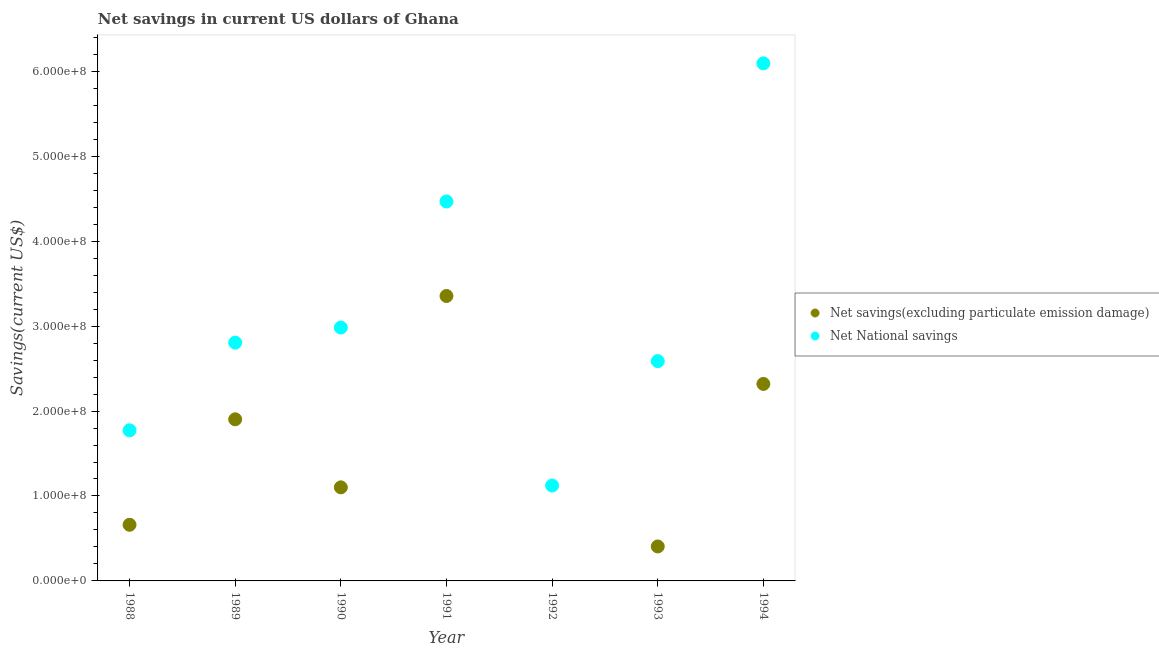How many different coloured dotlines are there?
Make the answer very short. 2. Is the number of dotlines equal to the number of legend labels?
Give a very brief answer. No. What is the net savings(excluding particulate emission damage) in 1991?
Provide a short and direct response. 3.35e+08. Across all years, what is the maximum net savings(excluding particulate emission damage)?
Ensure brevity in your answer.  3.35e+08. Across all years, what is the minimum net national savings?
Your answer should be very brief. 1.12e+08. What is the total net savings(excluding particulate emission damage) in the graph?
Keep it short and to the point. 9.75e+08. What is the difference between the net national savings in 1990 and that in 1991?
Provide a short and direct response. -1.48e+08. What is the difference between the net savings(excluding particulate emission damage) in 1989 and the net national savings in 1988?
Your response must be concise. 1.30e+07. What is the average net national savings per year?
Ensure brevity in your answer.  3.12e+08. In the year 1994, what is the difference between the net national savings and net savings(excluding particulate emission damage)?
Provide a succinct answer. 3.77e+08. What is the ratio of the net national savings in 1990 to that in 1994?
Provide a short and direct response. 0.49. Is the difference between the net savings(excluding particulate emission damage) in 1988 and 1993 greater than the difference between the net national savings in 1988 and 1993?
Ensure brevity in your answer.  Yes. What is the difference between the highest and the second highest net national savings?
Offer a very short reply. 1.63e+08. What is the difference between the highest and the lowest net national savings?
Give a very brief answer. 4.97e+08. In how many years, is the net national savings greater than the average net national savings taken over all years?
Keep it short and to the point. 2. Is the sum of the net national savings in 1990 and 1991 greater than the maximum net savings(excluding particulate emission damage) across all years?
Your answer should be compact. Yes. Is the net national savings strictly greater than the net savings(excluding particulate emission damage) over the years?
Offer a terse response. Yes. Is the net savings(excluding particulate emission damage) strictly less than the net national savings over the years?
Make the answer very short. Yes. How many years are there in the graph?
Make the answer very short. 7. What is the difference between two consecutive major ticks on the Y-axis?
Your answer should be very brief. 1.00e+08. Are the values on the major ticks of Y-axis written in scientific E-notation?
Offer a very short reply. Yes. How many legend labels are there?
Ensure brevity in your answer.  2. What is the title of the graph?
Your answer should be very brief. Net savings in current US dollars of Ghana. Does "Males" appear as one of the legend labels in the graph?
Ensure brevity in your answer.  No. What is the label or title of the Y-axis?
Give a very brief answer. Savings(current US$). What is the Savings(current US$) in Net savings(excluding particulate emission damage) in 1988?
Your response must be concise. 6.61e+07. What is the Savings(current US$) of Net National savings in 1988?
Your answer should be very brief. 1.77e+08. What is the Savings(current US$) in Net savings(excluding particulate emission damage) in 1989?
Your answer should be compact. 1.90e+08. What is the Savings(current US$) of Net National savings in 1989?
Your answer should be very brief. 2.81e+08. What is the Savings(current US$) in Net savings(excluding particulate emission damage) in 1990?
Provide a short and direct response. 1.10e+08. What is the Savings(current US$) of Net National savings in 1990?
Offer a terse response. 2.98e+08. What is the Savings(current US$) of Net savings(excluding particulate emission damage) in 1991?
Your answer should be very brief. 3.35e+08. What is the Savings(current US$) in Net National savings in 1991?
Your answer should be compact. 4.47e+08. What is the Savings(current US$) of Net savings(excluding particulate emission damage) in 1992?
Provide a succinct answer. 0. What is the Savings(current US$) in Net National savings in 1992?
Provide a succinct answer. 1.12e+08. What is the Savings(current US$) in Net savings(excluding particulate emission damage) in 1993?
Offer a very short reply. 4.06e+07. What is the Savings(current US$) of Net National savings in 1993?
Provide a succinct answer. 2.59e+08. What is the Savings(current US$) of Net savings(excluding particulate emission damage) in 1994?
Your response must be concise. 2.32e+08. What is the Savings(current US$) in Net National savings in 1994?
Give a very brief answer. 6.09e+08. Across all years, what is the maximum Savings(current US$) in Net savings(excluding particulate emission damage)?
Your answer should be very brief. 3.35e+08. Across all years, what is the maximum Savings(current US$) of Net National savings?
Provide a short and direct response. 6.09e+08. Across all years, what is the minimum Savings(current US$) of Net National savings?
Provide a short and direct response. 1.12e+08. What is the total Savings(current US$) in Net savings(excluding particulate emission damage) in the graph?
Make the answer very short. 9.75e+08. What is the total Savings(current US$) of Net National savings in the graph?
Your answer should be very brief. 2.18e+09. What is the difference between the Savings(current US$) of Net savings(excluding particulate emission damage) in 1988 and that in 1989?
Your response must be concise. -1.24e+08. What is the difference between the Savings(current US$) of Net National savings in 1988 and that in 1989?
Make the answer very short. -1.03e+08. What is the difference between the Savings(current US$) of Net savings(excluding particulate emission damage) in 1988 and that in 1990?
Provide a short and direct response. -4.41e+07. What is the difference between the Savings(current US$) of Net National savings in 1988 and that in 1990?
Your answer should be very brief. -1.21e+08. What is the difference between the Savings(current US$) of Net savings(excluding particulate emission damage) in 1988 and that in 1991?
Your answer should be compact. -2.69e+08. What is the difference between the Savings(current US$) in Net National savings in 1988 and that in 1991?
Offer a very short reply. -2.69e+08. What is the difference between the Savings(current US$) in Net National savings in 1988 and that in 1992?
Give a very brief answer. 6.51e+07. What is the difference between the Savings(current US$) in Net savings(excluding particulate emission damage) in 1988 and that in 1993?
Offer a terse response. 2.55e+07. What is the difference between the Savings(current US$) of Net National savings in 1988 and that in 1993?
Keep it short and to the point. -8.14e+07. What is the difference between the Savings(current US$) of Net savings(excluding particulate emission damage) in 1988 and that in 1994?
Your response must be concise. -1.66e+08. What is the difference between the Savings(current US$) in Net National savings in 1988 and that in 1994?
Your answer should be very brief. -4.32e+08. What is the difference between the Savings(current US$) of Net savings(excluding particulate emission damage) in 1989 and that in 1990?
Offer a terse response. 8.01e+07. What is the difference between the Savings(current US$) in Net National savings in 1989 and that in 1990?
Give a very brief answer. -1.78e+07. What is the difference between the Savings(current US$) in Net savings(excluding particulate emission damage) in 1989 and that in 1991?
Ensure brevity in your answer.  -1.45e+08. What is the difference between the Savings(current US$) of Net National savings in 1989 and that in 1991?
Your answer should be compact. -1.66e+08. What is the difference between the Savings(current US$) in Net National savings in 1989 and that in 1992?
Ensure brevity in your answer.  1.68e+08. What is the difference between the Savings(current US$) in Net savings(excluding particulate emission damage) in 1989 and that in 1993?
Keep it short and to the point. 1.50e+08. What is the difference between the Savings(current US$) of Net National savings in 1989 and that in 1993?
Your answer should be compact. 2.18e+07. What is the difference between the Savings(current US$) of Net savings(excluding particulate emission damage) in 1989 and that in 1994?
Make the answer very short. -4.17e+07. What is the difference between the Savings(current US$) of Net National savings in 1989 and that in 1994?
Your response must be concise. -3.29e+08. What is the difference between the Savings(current US$) in Net savings(excluding particulate emission damage) in 1990 and that in 1991?
Provide a succinct answer. -2.25e+08. What is the difference between the Savings(current US$) in Net National savings in 1990 and that in 1991?
Provide a succinct answer. -1.48e+08. What is the difference between the Savings(current US$) of Net National savings in 1990 and that in 1992?
Ensure brevity in your answer.  1.86e+08. What is the difference between the Savings(current US$) in Net savings(excluding particulate emission damage) in 1990 and that in 1993?
Your answer should be compact. 6.96e+07. What is the difference between the Savings(current US$) in Net National savings in 1990 and that in 1993?
Your answer should be compact. 3.95e+07. What is the difference between the Savings(current US$) of Net savings(excluding particulate emission damage) in 1990 and that in 1994?
Provide a succinct answer. -1.22e+08. What is the difference between the Savings(current US$) in Net National savings in 1990 and that in 1994?
Keep it short and to the point. -3.11e+08. What is the difference between the Savings(current US$) in Net National savings in 1991 and that in 1992?
Provide a short and direct response. 3.34e+08. What is the difference between the Savings(current US$) of Net savings(excluding particulate emission damage) in 1991 and that in 1993?
Your answer should be compact. 2.95e+08. What is the difference between the Savings(current US$) of Net National savings in 1991 and that in 1993?
Your answer should be very brief. 1.88e+08. What is the difference between the Savings(current US$) of Net savings(excluding particulate emission damage) in 1991 and that in 1994?
Your response must be concise. 1.04e+08. What is the difference between the Savings(current US$) in Net National savings in 1991 and that in 1994?
Your response must be concise. -1.63e+08. What is the difference between the Savings(current US$) in Net National savings in 1992 and that in 1993?
Make the answer very short. -1.46e+08. What is the difference between the Savings(current US$) of Net National savings in 1992 and that in 1994?
Your response must be concise. -4.97e+08. What is the difference between the Savings(current US$) in Net savings(excluding particulate emission damage) in 1993 and that in 1994?
Ensure brevity in your answer.  -1.91e+08. What is the difference between the Savings(current US$) of Net National savings in 1993 and that in 1994?
Provide a succinct answer. -3.51e+08. What is the difference between the Savings(current US$) in Net savings(excluding particulate emission damage) in 1988 and the Savings(current US$) in Net National savings in 1989?
Your answer should be very brief. -2.14e+08. What is the difference between the Savings(current US$) in Net savings(excluding particulate emission damage) in 1988 and the Savings(current US$) in Net National savings in 1990?
Provide a succinct answer. -2.32e+08. What is the difference between the Savings(current US$) in Net savings(excluding particulate emission damage) in 1988 and the Savings(current US$) in Net National savings in 1991?
Give a very brief answer. -3.81e+08. What is the difference between the Savings(current US$) in Net savings(excluding particulate emission damage) in 1988 and the Savings(current US$) in Net National savings in 1992?
Give a very brief answer. -4.62e+07. What is the difference between the Savings(current US$) in Net savings(excluding particulate emission damage) in 1988 and the Savings(current US$) in Net National savings in 1993?
Make the answer very short. -1.93e+08. What is the difference between the Savings(current US$) in Net savings(excluding particulate emission damage) in 1988 and the Savings(current US$) in Net National savings in 1994?
Your answer should be very brief. -5.43e+08. What is the difference between the Savings(current US$) in Net savings(excluding particulate emission damage) in 1989 and the Savings(current US$) in Net National savings in 1990?
Ensure brevity in your answer.  -1.08e+08. What is the difference between the Savings(current US$) in Net savings(excluding particulate emission damage) in 1989 and the Savings(current US$) in Net National savings in 1991?
Give a very brief answer. -2.56e+08. What is the difference between the Savings(current US$) of Net savings(excluding particulate emission damage) in 1989 and the Savings(current US$) of Net National savings in 1992?
Your answer should be compact. 7.80e+07. What is the difference between the Savings(current US$) in Net savings(excluding particulate emission damage) in 1989 and the Savings(current US$) in Net National savings in 1993?
Your response must be concise. -6.85e+07. What is the difference between the Savings(current US$) of Net savings(excluding particulate emission damage) in 1989 and the Savings(current US$) of Net National savings in 1994?
Provide a short and direct response. -4.19e+08. What is the difference between the Savings(current US$) in Net savings(excluding particulate emission damage) in 1990 and the Savings(current US$) in Net National savings in 1991?
Your response must be concise. -3.37e+08. What is the difference between the Savings(current US$) of Net savings(excluding particulate emission damage) in 1990 and the Savings(current US$) of Net National savings in 1992?
Give a very brief answer. -2.10e+06. What is the difference between the Savings(current US$) in Net savings(excluding particulate emission damage) in 1990 and the Savings(current US$) in Net National savings in 1993?
Your answer should be very brief. -1.49e+08. What is the difference between the Savings(current US$) in Net savings(excluding particulate emission damage) in 1990 and the Savings(current US$) in Net National savings in 1994?
Ensure brevity in your answer.  -4.99e+08. What is the difference between the Savings(current US$) in Net savings(excluding particulate emission damage) in 1991 and the Savings(current US$) in Net National savings in 1992?
Provide a short and direct response. 2.23e+08. What is the difference between the Savings(current US$) in Net savings(excluding particulate emission damage) in 1991 and the Savings(current US$) in Net National savings in 1993?
Offer a terse response. 7.67e+07. What is the difference between the Savings(current US$) of Net savings(excluding particulate emission damage) in 1991 and the Savings(current US$) of Net National savings in 1994?
Provide a succinct answer. -2.74e+08. What is the difference between the Savings(current US$) of Net savings(excluding particulate emission damage) in 1993 and the Savings(current US$) of Net National savings in 1994?
Keep it short and to the point. -5.69e+08. What is the average Savings(current US$) in Net savings(excluding particulate emission damage) per year?
Provide a succinct answer. 1.39e+08. What is the average Savings(current US$) of Net National savings per year?
Keep it short and to the point. 3.12e+08. In the year 1988, what is the difference between the Savings(current US$) of Net savings(excluding particulate emission damage) and Savings(current US$) of Net National savings?
Your answer should be very brief. -1.11e+08. In the year 1989, what is the difference between the Savings(current US$) of Net savings(excluding particulate emission damage) and Savings(current US$) of Net National savings?
Keep it short and to the point. -9.03e+07. In the year 1990, what is the difference between the Savings(current US$) in Net savings(excluding particulate emission damage) and Savings(current US$) in Net National savings?
Your answer should be compact. -1.88e+08. In the year 1991, what is the difference between the Savings(current US$) in Net savings(excluding particulate emission damage) and Savings(current US$) in Net National savings?
Provide a succinct answer. -1.11e+08. In the year 1993, what is the difference between the Savings(current US$) in Net savings(excluding particulate emission damage) and Savings(current US$) in Net National savings?
Keep it short and to the point. -2.18e+08. In the year 1994, what is the difference between the Savings(current US$) of Net savings(excluding particulate emission damage) and Savings(current US$) of Net National savings?
Ensure brevity in your answer.  -3.77e+08. What is the ratio of the Savings(current US$) of Net savings(excluding particulate emission damage) in 1988 to that in 1989?
Your answer should be very brief. 0.35. What is the ratio of the Savings(current US$) in Net National savings in 1988 to that in 1989?
Your answer should be very brief. 0.63. What is the ratio of the Savings(current US$) of Net National savings in 1988 to that in 1990?
Offer a very short reply. 0.59. What is the ratio of the Savings(current US$) in Net savings(excluding particulate emission damage) in 1988 to that in 1991?
Your response must be concise. 0.2. What is the ratio of the Savings(current US$) in Net National savings in 1988 to that in 1991?
Provide a succinct answer. 0.4. What is the ratio of the Savings(current US$) of Net National savings in 1988 to that in 1992?
Your answer should be very brief. 1.58. What is the ratio of the Savings(current US$) in Net savings(excluding particulate emission damage) in 1988 to that in 1993?
Ensure brevity in your answer.  1.63. What is the ratio of the Savings(current US$) of Net National savings in 1988 to that in 1993?
Your answer should be compact. 0.69. What is the ratio of the Savings(current US$) of Net savings(excluding particulate emission damage) in 1988 to that in 1994?
Provide a succinct answer. 0.28. What is the ratio of the Savings(current US$) of Net National savings in 1988 to that in 1994?
Provide a short and direct response. 0.29. What is the ratio of the Savings(current US$) of Net savings(excluding particulate emission damage) in 1989 to that in 1990?
Provide a short and direct response. 1.73. What is the ratio of the Savings(current US$) of Net National savings in 1989 to that in 1990?
Your response must be concise. 0.94. What is the ratio of the Savings(current US$) of Net savings(excluding particulate emission damage) in 1989 to that in 1991?
Offer a very short reply. 0.57. What is the ratio of the Savings(current US$) in Net National savings in 1989 to that in 1991?
Keep it short and to the point. 0.63. What is the ratio of the Savings(current US$) in Net National savings in 1989 to that in 1992?
Ensure brevity in your answer.  2.5. What is the ratio of the Savings(current US$) in Net savings(excluding particulate emission damage) in 1989 to that in 1993?
Keep it short and to the point. 4.69. What is the ratio of the Savings(current US$) of Net National savings in 1989 to that in 1993?
Keep it short and to the point. 1.08. What is the ratio of the Savings(current US$) in Net savings(excluding particulate emission damage) in 1989 to that in 1994?
Offer a very short reply. 0.82. What is the ratio of the Savings(current US$) of Net National savings in 1989 to that in 1994?
Provide a succinct answer. 0.46. What is the ratio of the Savings(current US$) of Net savings(excluding particulate emission damage) in 1990 to that in 1991?
Your answer should be very brief. 0.33. What is the ratio of the Savings(current US$) in Net National savings in 1990 to that in 1991?
Ensure brevity in your answer.  0.67. What is the ratio of the Savings(current US$) in Net National savings in 1990 to that in 1992?
Provide a succinct answer. 2.66. What is the ratio of the Savings(current US$) in Net savings(excluding particulate emission damage) in 1990 to that in 1993?
Give a very brief answer. 2.71. What is the ratio of the Savings(current US$) in Net National savings in 1990 to that in 1993?
Offer a terse response. 1.15. What is the ratio of the Savings(current US$) of Net savings(excluding particulate emission damage) in 1990 to that in 1994?
Provide a succinct answer. 0.47. What is the ratio of the Savings(current US$) in Net National savings in 1990 to that in 1994?
Keep it short and to the point. 0.49. What is the ratio of the Savings(current US$) of Net National savings in 1991 to that in 1992?
Your answer should be very brief. 3.98. What is the ratio of the Savings(current US$) of Net savings(excluding particulate emission damage) in 1991 to that in 1993?
Provide a short and direct response. 8.26. What is the ratio of the Savings(current US$) of Net National savings in 1991 to that in 1993?
Your answer should be compact. 1.73. What is the ratio of the Savings(current US$) of Net savings(excluding particulate emission damage) in 1991 to that in 1994?
Your answer should be very brief. 1.45. What is the ratio of the Savings(current US$) in Net National savings in 1991 to that in 1994?
Ensure brevity in your answer.  0.73. What is the ratio of the Savings(current US$) of Net National savings in 1992 to that in 1993?
Keep it short and to the point. 0.43. What is the ratio of the Savings(current US$) of Net National savings in 1992 to that in 1994?
Offer a very short reply. 0.18. What is the ratio of the Savings(current US$) of Net savings(excluding particulate emission damage) in 1993 to that in 1994?
Keep it short and to the point. 0.17. What is the ratio of the Savings(current US$) in Net National savings in 1993 to that in 1994?
Your response must be concise. 0.42. What is the difference between the highest and the second highest Savings(current US$) of Net savings(excluding particulate emission damage)?
Give a very brief answer. 1.04e+08. What is the difference between the highest and the second highest Savings(current US$) of Net National savings?
Offer a terse response. 1.63e+08. What is the difference between the highest and the lowest Savings(current US$) of Net savings(excluding particulate emission damage)?
Provide a succinct answer. 3.35e+08. What is the difference between the highest and the lowest Savings(current US$) of Net National savings?
Provide a short and direct response. 4.97e+08. 